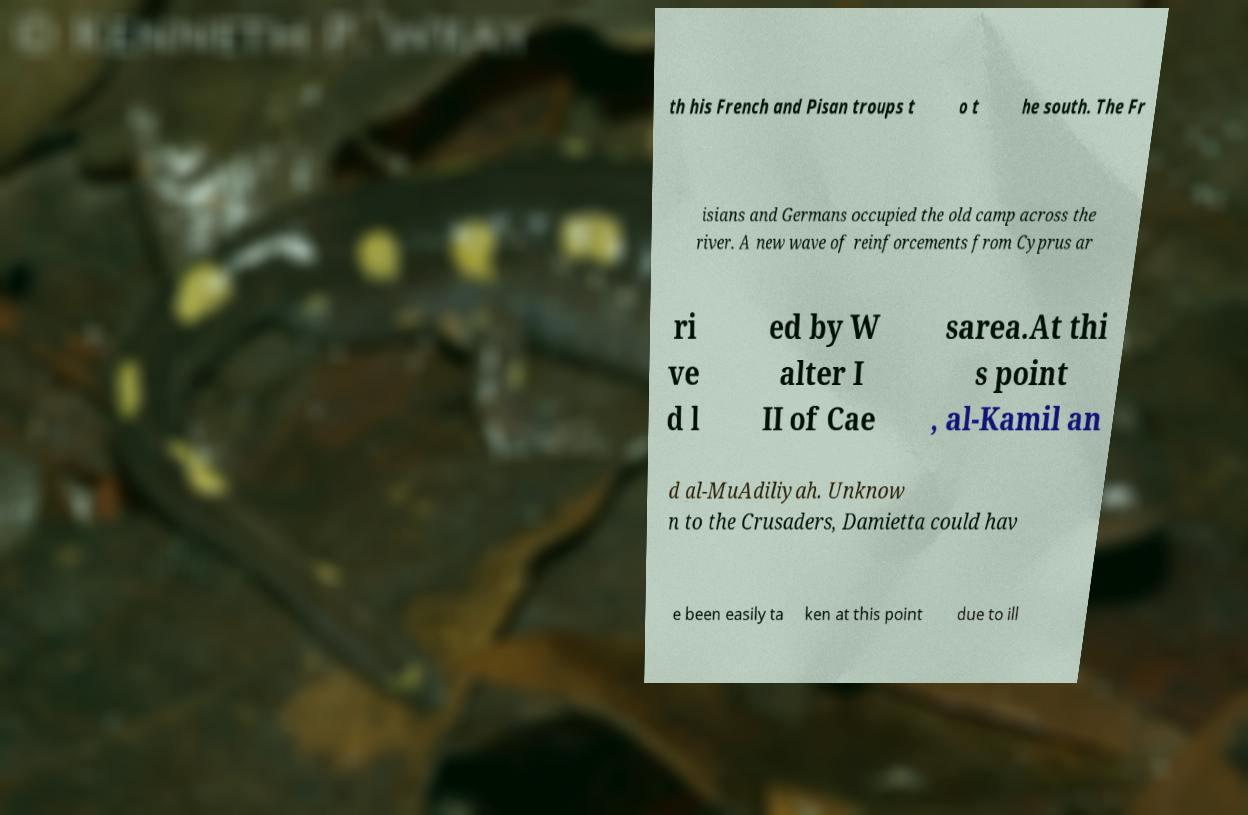I need the written content from this picture converted into text. Can you do that? th his French and Pisan troups t o t he south. The Fr isians and Germans occupied the old camp across the river. A new wave of reinforcements from Cyprus ar ri ve d l ed by W alter I II of Cae sarea.At thi s point , al-Kamil an d al-MuAdiliyah. Unknow n to the Crusaders, Damietta could hav e been easily ta ken at this point due to ill 